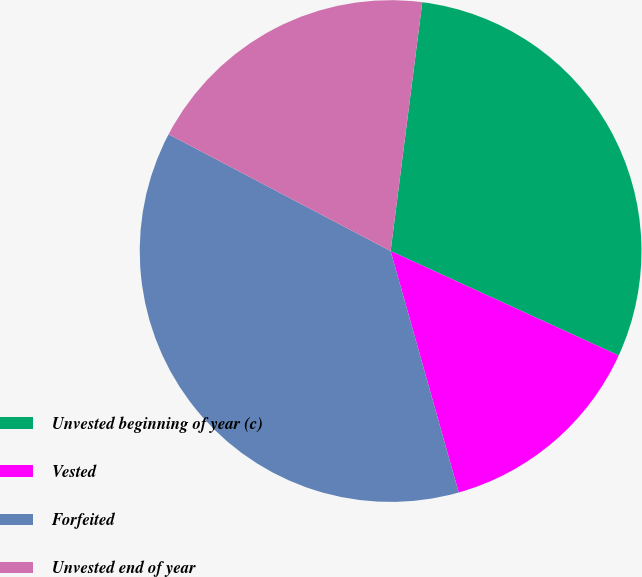<chart> <loc_0><loc_0><loc_500><loc_500><pie_chart><fcel>Unvested beginning of year (c)<fcel>Vested<fcel>Forfeited<fcel>Unvested end of year<nl><fcel>29.82%<fcel>13.79%<fcel>37.08%<fcel>19.31%<nl></chart> 